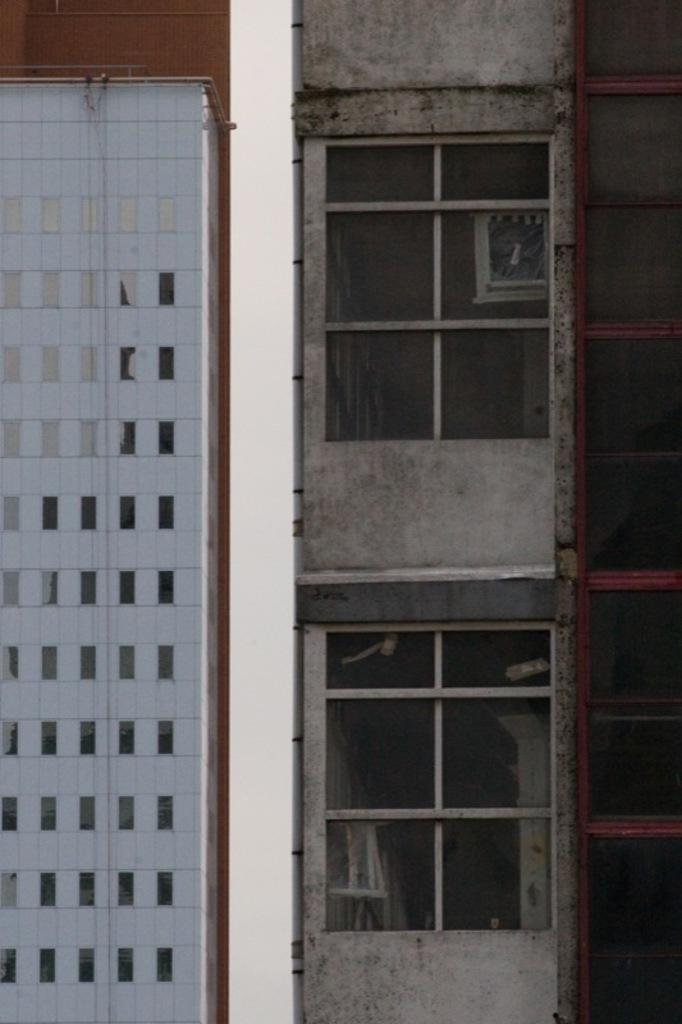What type of structures are present in the image? There are buildings in the image. What feature can be seen on the buildings? The buildings have windows. What verse is being recited by the buildings in the image? There is no verse being recited by the buildings in the image, as buildings are inanimate structures and cannot recite verses. 